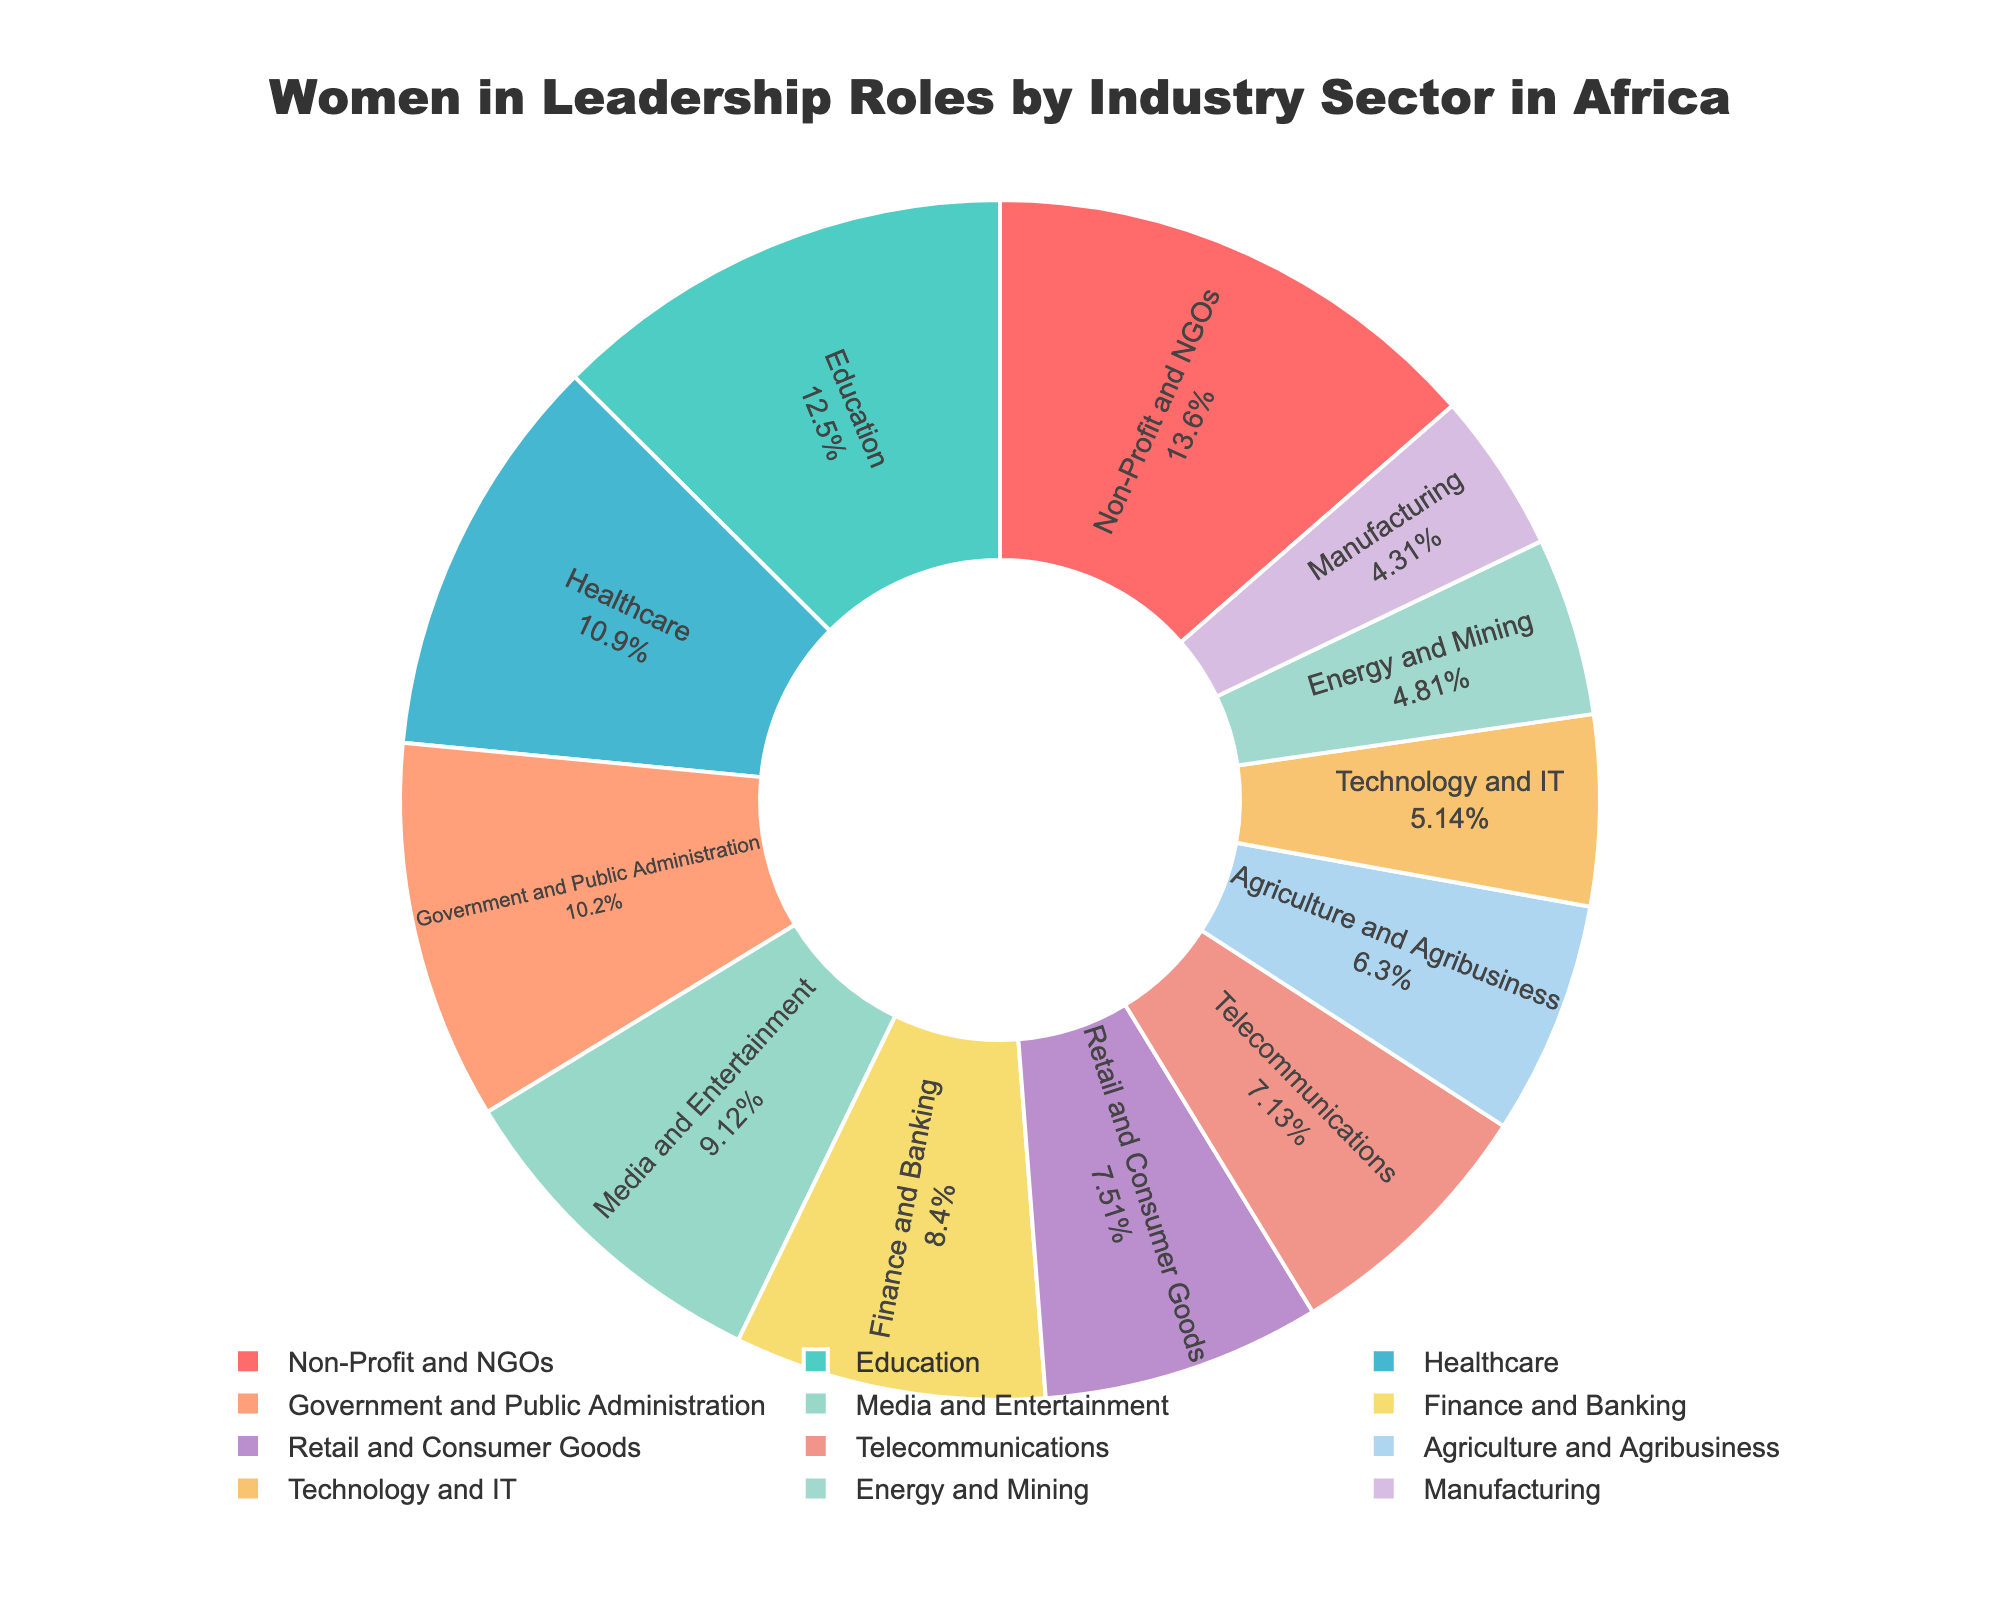What percentage of women in leadership roles is in the Healthcare sector? Look for the value corresponding to the Healthcare sector slice in the pie chart.
Answer: 19.8% Which industry sector has the highest percentage of women in leadership roles? Identify the largest slice in the pie chart by comparing the sizes/percentages.
Answer: Non-Profit and NGOs What is the combined percentage of women in leadership roles in the Technology and IT and Energy and Mining sectors? Add the percentages of the Technology and IT sector (9.3%) and the Energy and Mining sector (8.7%).
Answer: 18.0% Compare the percentage of women in leadership roles in the Education sector versus the Manufacturing sector. Which is higher and by how much? Subtract the Manufacturing sector percentage from the Education sector percentage (22.7% - 7.8%).
Answer: Education, 14.9% Which three sectors have the lowest percentages of women in leadership roles, and what are their percentages? Identify and list the three smallest slices in the pie chart and their corresponding percentages.
Answer: Manufacturing (7.8%), Technology and IT (9.3%), Energy and Mining (8.7%) What is the difference in the percentage of women in leadership roles between the Retail and Consumer Goods sector and the Finance and Banking sector? Subtract the Finance and Banking sector percentage from the Retail and Consumer Goods sector percentage (13.6% - 15.2%).
Answer: -1.6% Arrange the following sectors in descending order based on the percentage of women in leadership roles: Government and Public Administration, Media and Entertainment, Agriculture and Agribusiness. Compare the slices for the specified sectors and list them in order from the highest to the lowest percentage.
Answer: Media and Entertainment (16.5%), Government and Public Administration (18.5%), Agriculture and Agribusiness (11.4%) What color represents the Non-Profit and NGOs sector in the pie chart? Find the slice labeled 'Non-Profit and NGOs' and identify the fill color of that slice.
Answer: Yellow 